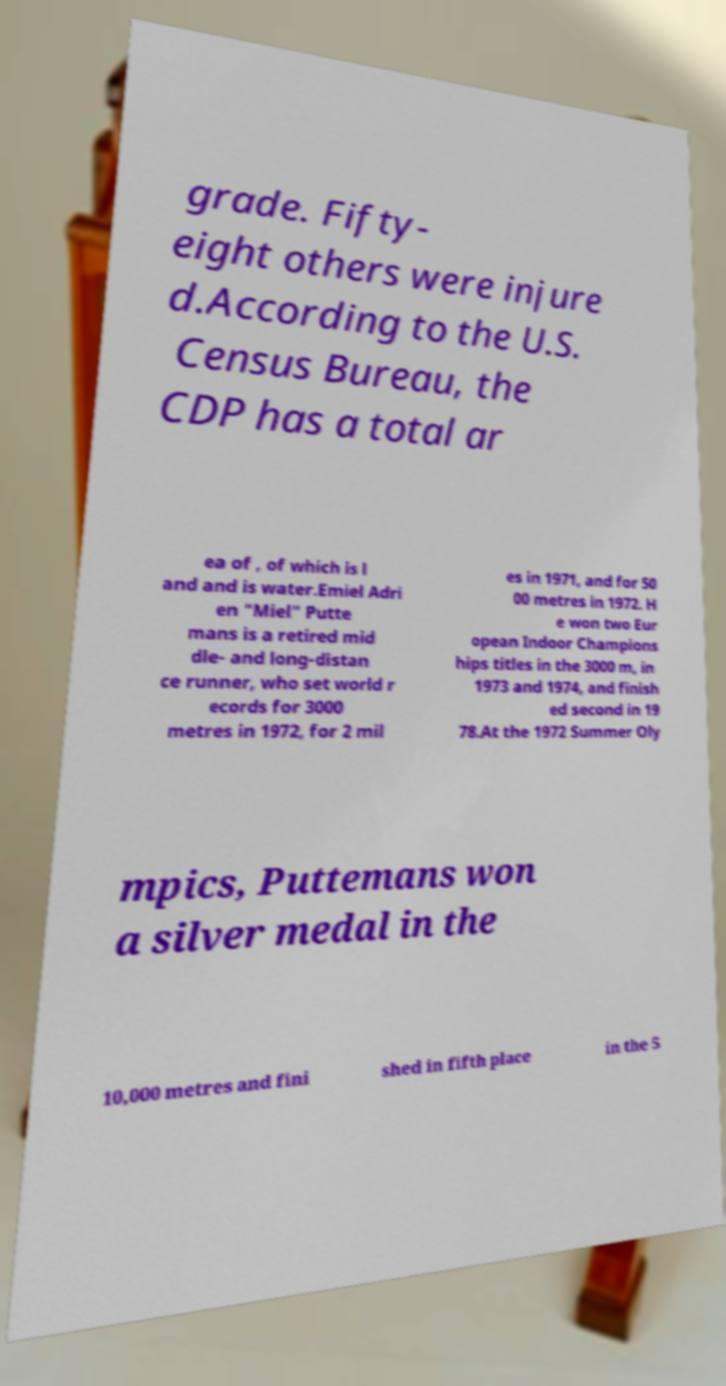There's text embedded in this image that I need extracted. Can you transcribe it verbatim? grade. Fifty- eight others were injure d.According to the U.S. Census Bureau, the CDP has a total ar ea of , of which is l and and is water.Emiel Adri en "Miel" Putte mans is a retired mid dle- and long-distan ce runner, who set world r ecords for 3000 metres in 1972, for 2 mil es in 1971, and for 50 00 metres in 1972. H e won two Eur opean Indoor Champions hips titles in the 3000 m, in 1973 and 1974, and finish ed second in 19 78.At the 1972 Summer Oly mpics, Puttemans won a silver medal in the 10,000 metres and fini shed in fifth place in the 5 